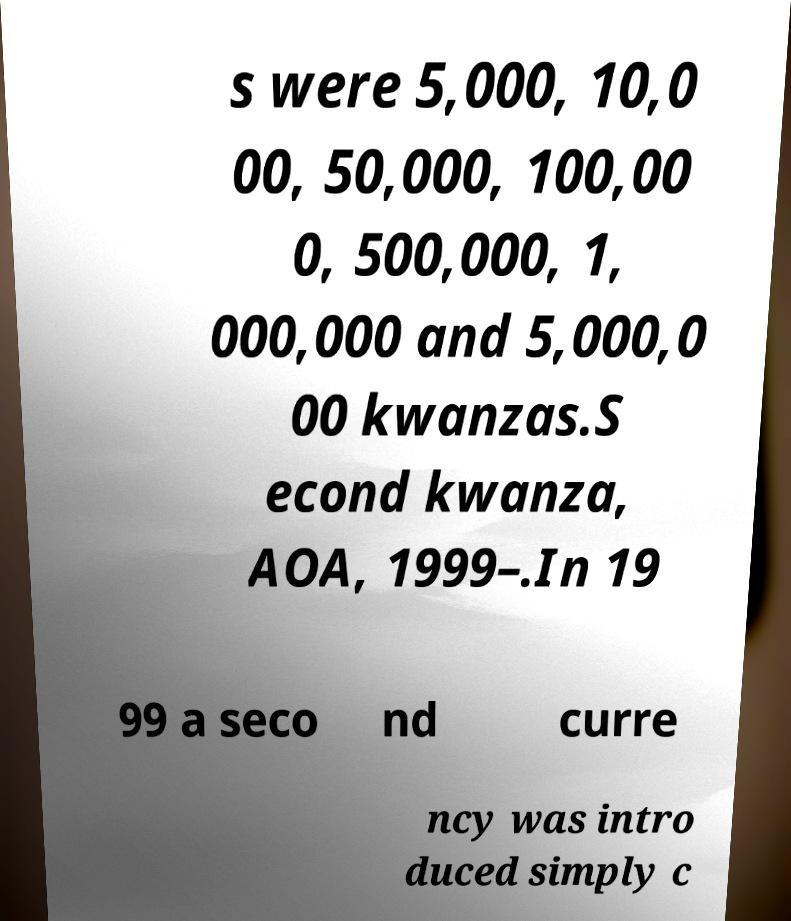For documentation purposes, I need the text within this image transcribed. Could you provide that? s were 5,000, 10,0 00, 50,000, 100,00 0, 500,000, 1, 000,000 and 5,000,0 00 kwanzas.S econd kwanza, AOA, 1999–.In 19 99 a seco nd curre ncy was intro duced simply c 